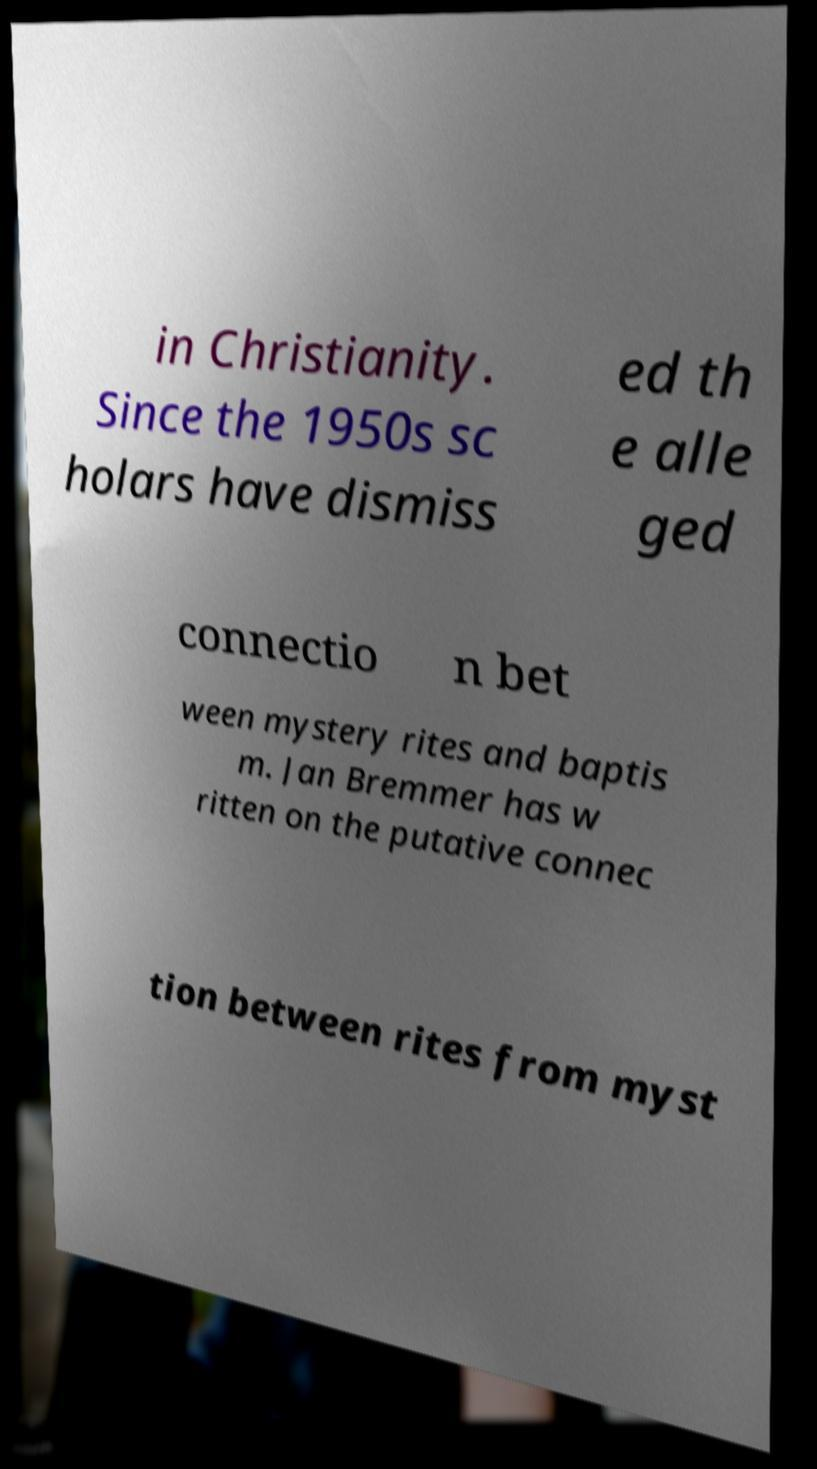Please identify and transcribe the text found in this image. in Christianity. Since the 1950s sc holars have dismiss ed th e alle ged connectio n bet ween mystery rites and baptis m. Jan Bremmer has w ritten on the putative connec tion between rites from myst 